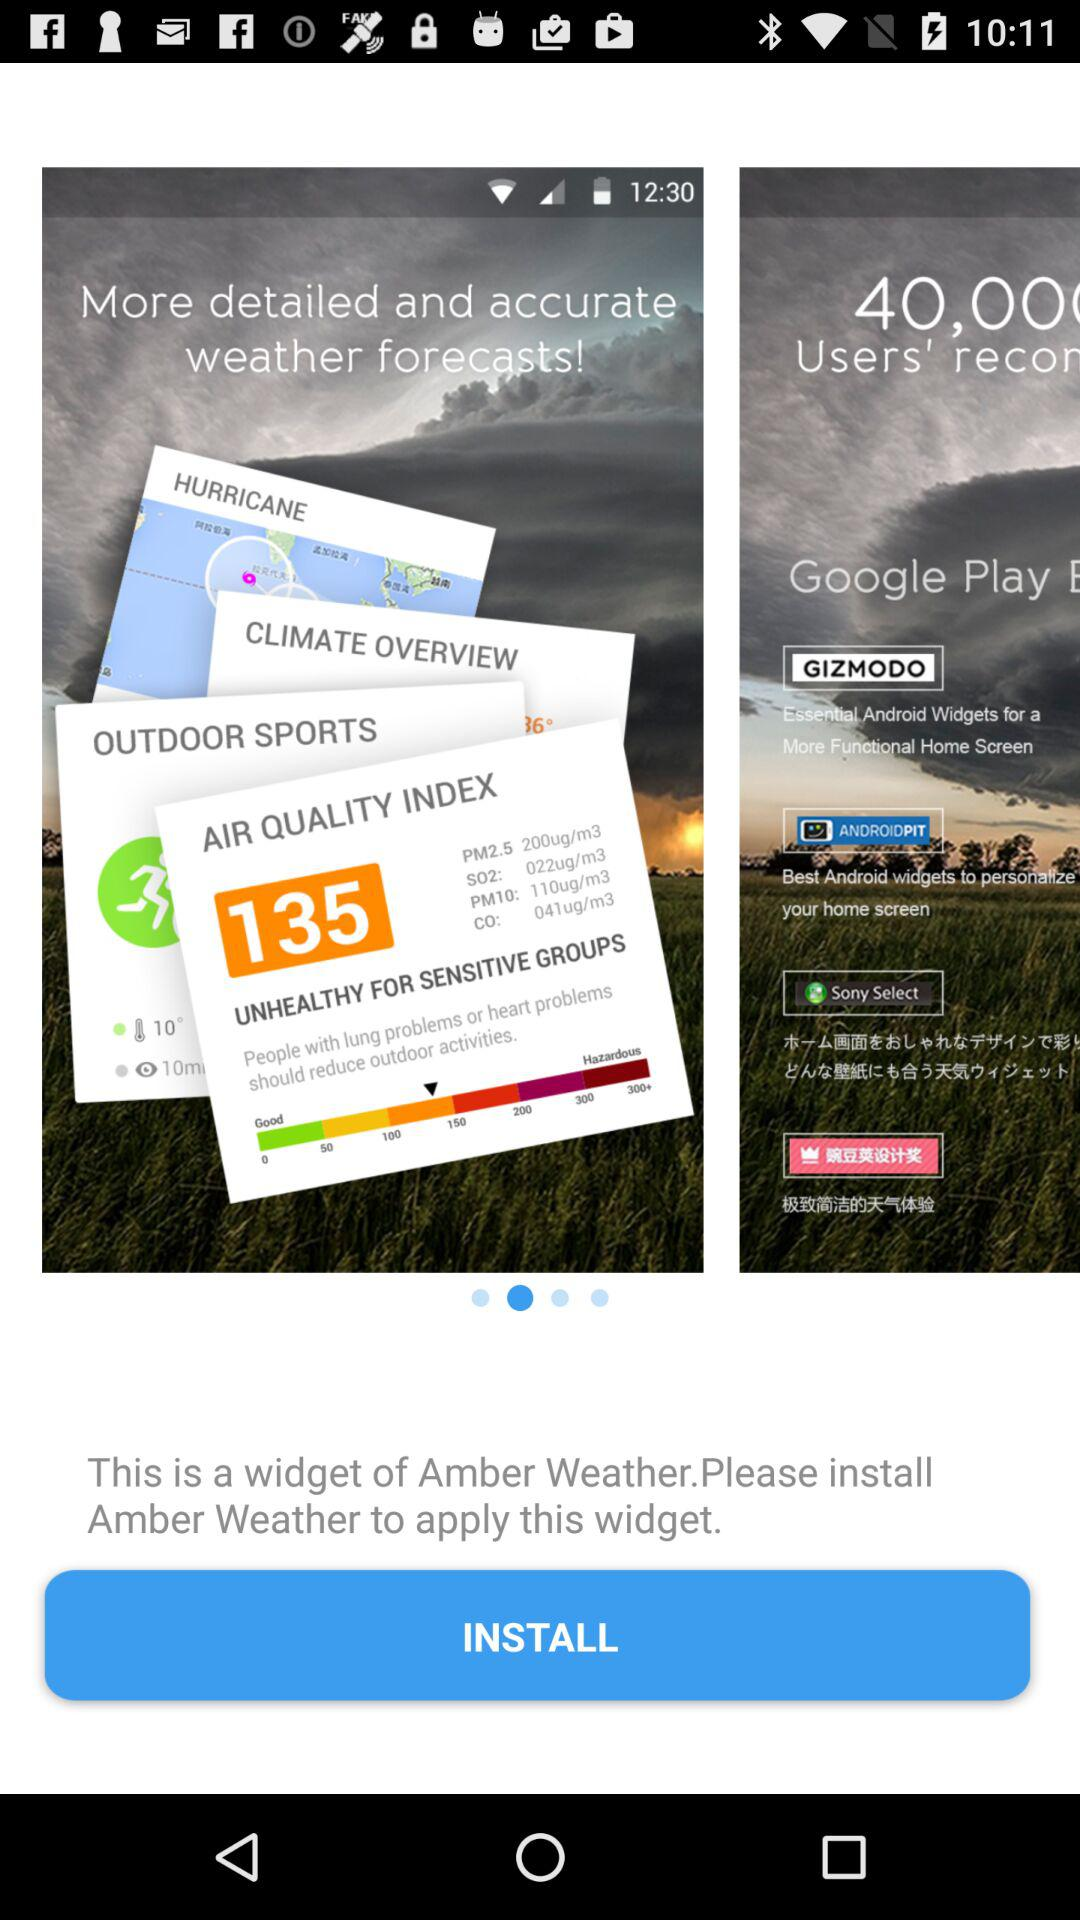What is the name of the application? The name of the application is "Amber Weather". 